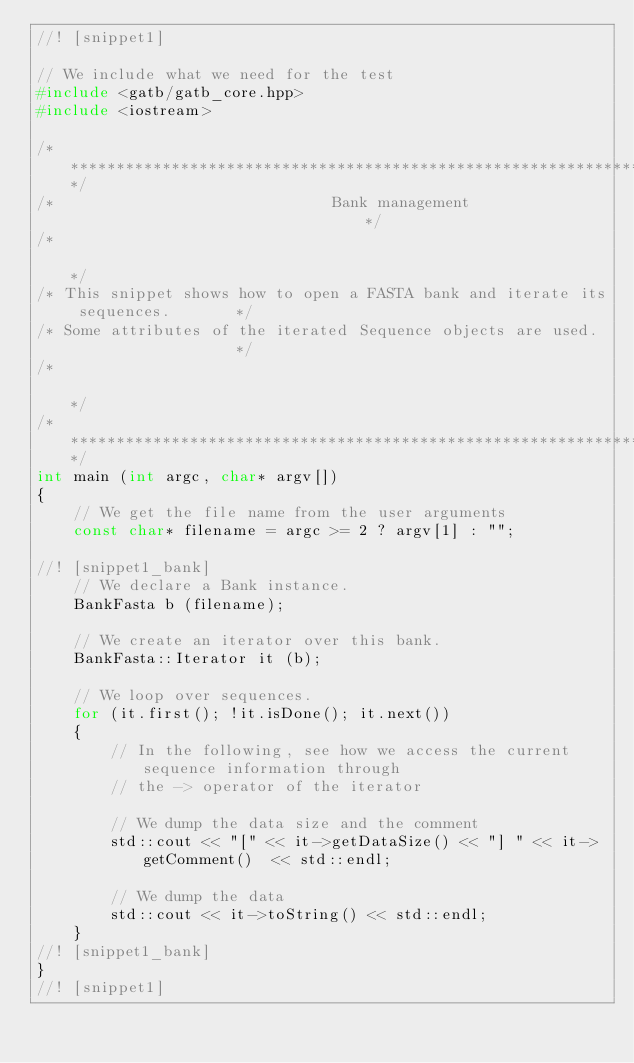<code> <loc_0><loc_0><loc_500><loc_500><_C++_>//! [snippet1]

// We include what we need for the test
#include <gatb/gatb_core.hpp>
#include <iostream>

/********************************************************************************/
/*                              Bank management                                 */
/*                                                                              */
/* This snippet shows how to open a FASTA bank and iterate its sequences.       */
/* Some attributes of the iterated Sequence objects are used.                   */
/*                                                                              */
/********************************************************************************/
int main (int argc, char* argv[])
{
    // We get the file name from the user arguments
    const char* filename = argc >= 2 ? argv[1] : "";

//! [snippet1_bank]
    // We declare a Bank instance.
    BankFasta b (filename);

    // We create an iterator over this bank.
    BankFasta::Iterator it (b);

    // We loop over sequences.
    for (it.first(); !it.isDone(); it.next())
    {
        // In the following, see how we access the current sequence information through
        // the -> operator of the iterator

        // We dump the data size and the comment
        std::cout << "[" << it->getDataSize() << "] " << it->getComment()  << std::endl;

        // We dump the data
        std::cout << it->toString() << std::endl;
    }
//! [snippet1_bank]
}
//! [snippet1]
</code> 